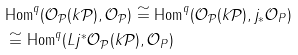Convert formula to latex. <formula><loc_0><loc_0><loc_500><loc_500>& \text {Hom} ^ { q } ( \mathcal { O } _ { \mathcal { P } } ( k \mathcal { P } ) , \mathcal { O } _ { \mathcal { P } } ) \cong \text {Hom} ^ { q } ( \mathcal { O } _ { \mathcal { P } } ( k \mathcal { P } ) , j _ { * } \mathcal { O } _ { P } ) \\ & \cong \text {Hom} ^ { q } ( L j ^ { * } \mathcal { O } _ { \mathcal { P } } ( k \mathcal { P } ) , \mathcal { O } _ { P } )</formula> 